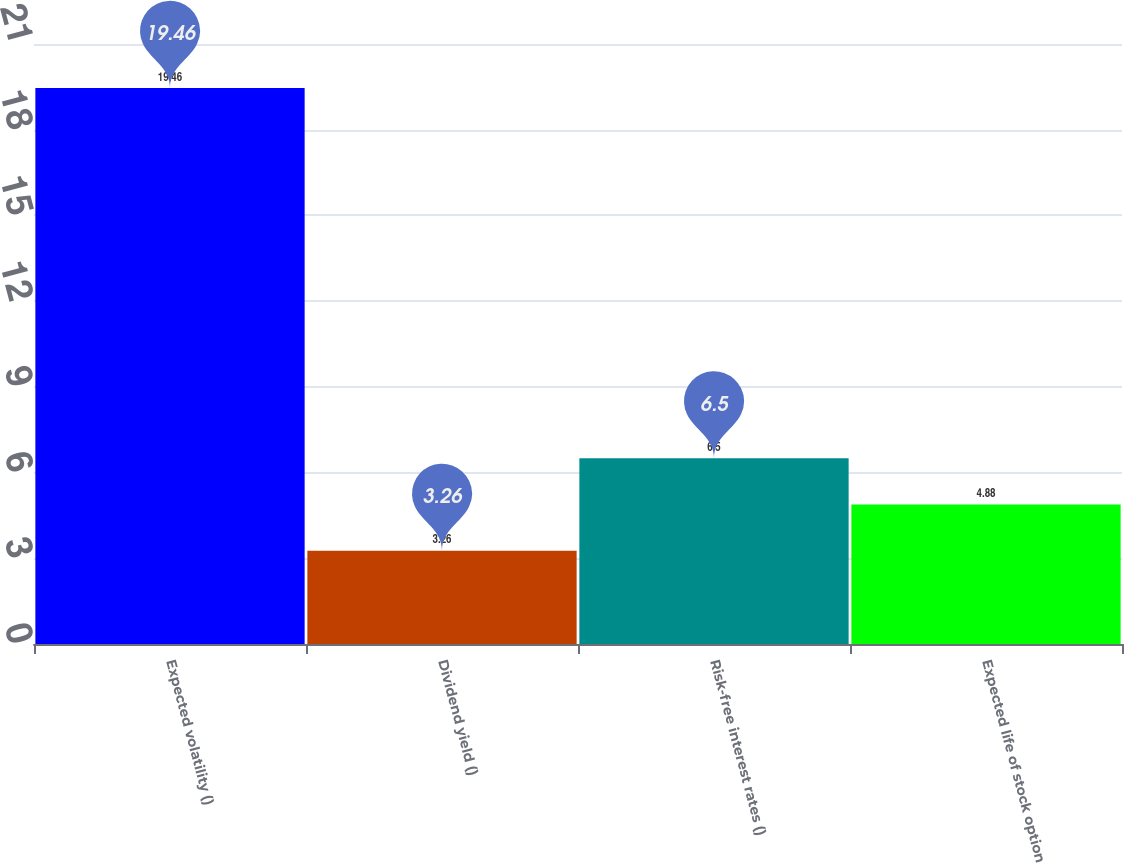Convert chart. <chart><loc_0><loc_0><loc_500><loc_500><bar_chart><fcel>Expected volatility ()<fcel>Dividend yield ()<fcel>Risk-free interest rates ()<fcel>Expected life of stock option<nl><fcel>19.46<fcel>3.26<fcel>6.5<fcel>4.88<nl></chart> 